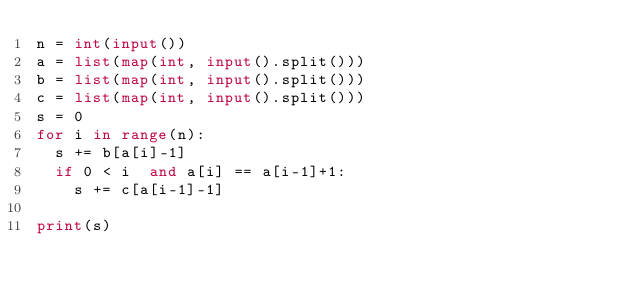<code> <loc_0><loc_0><loc_500><loc_500><_Python_>n = int(input())
a = list(map(int, input().split()))
b = list(map(int, input().split()))
c = list(map(int, input().split()))
s = 0
for i in range(n):
  s += b[a[i]-1]
  if 0 < i  and a[i] == a[i-1]+1:
    s += c[a[i-1]-1]

print(s)</code> 